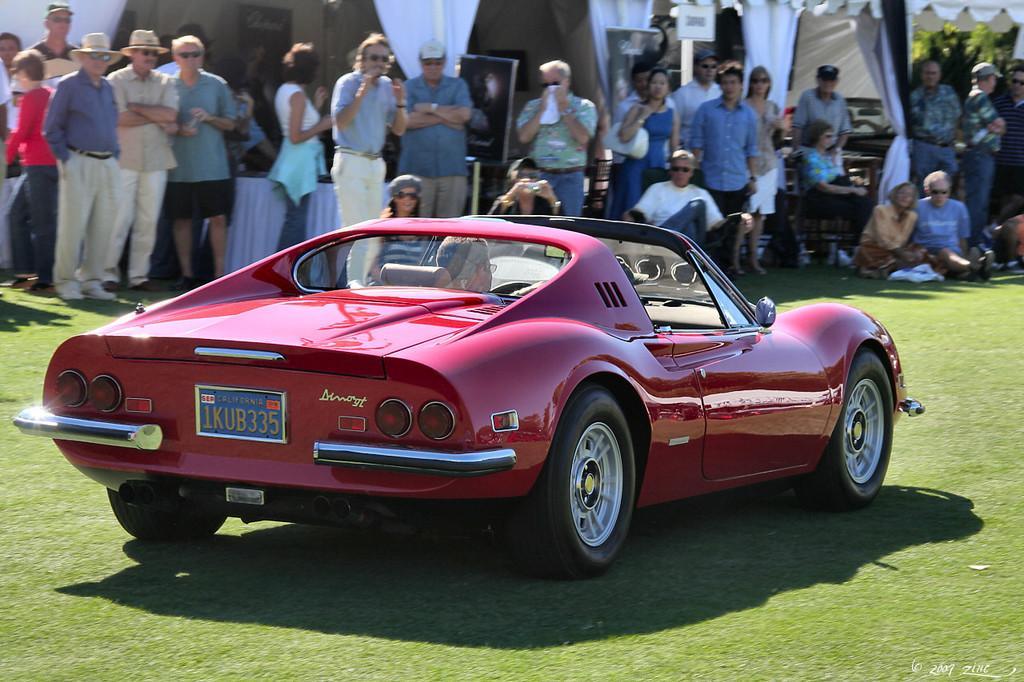In one or two sentences, can you explain what this image depicts? In this picture we can see a vehicle on the ground and in the background we can see a group of people, curtains and some objects. 